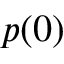Convert formula to latex. <formula><loc_0><loc_0><loc_500><loc_500>p ( 0 )</formula> 